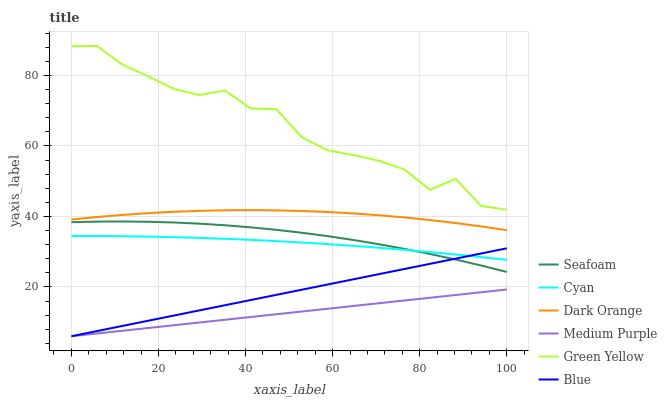Does Medium Purple have the minimum area under the curve?
Answer yes or no. Yes. Does Green Yellow have the maximum area under the curve?
Answer yes or no. Yes. Does Dark Orange have the minimum area under the curve?
Answer yes or no. No. Does Dark Orange have the maximum area under the curve?
Answer yes or no. No. Is Medium Purple the smoothest?
Answer yes or no. Yes. Is Green Yellow the roughest?
Answer yes or no. Yes. Is Dark Orange the smoothest?
Answer yes or no. No. Is Dark Orange the roughest?
Answer yes or no. No. Does Dark Orange have the lowest value?
Answer yes or no. No. Does Green Yellow have the highest value?
Answer yes or no. Yes. Does Dark Orange have the highest value?
Answer yes or no. No. Is Cyan less than Dark Orange?
Answer yes or no. Yes. Is Dark Orange greater than Medium Purple?
Answer yes or no. Yes. Does Blue intersect Medium Purple?
Answer yes or no. Yes. Is Blue less than Medium Purple?
Answer yes or no. No. Is Blue greater than Medium Purple?
Answer yes or no. No. Does Cyan intersect Dark Orange?
Answer yes or no. No. 